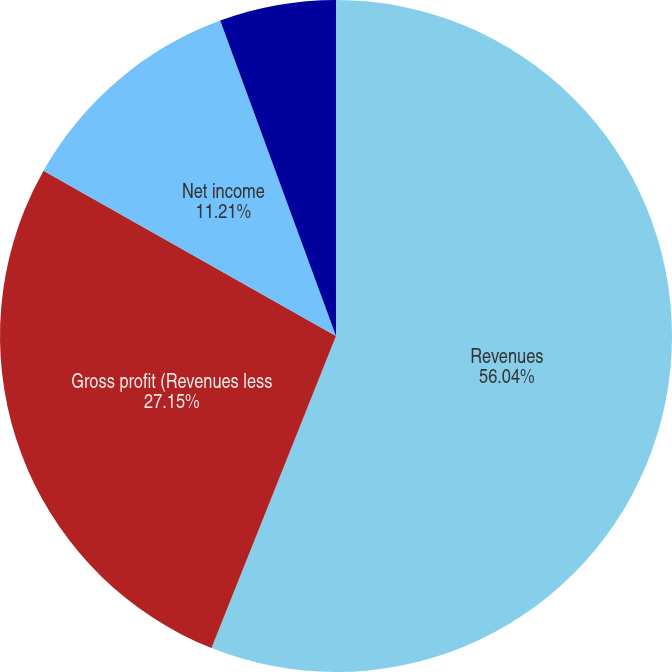Convert chart. <chart><loc_0><loc_0><loc_500><loc_500><pie_chart><fcel>Revenues<fcel>Gross profit (Revenues less<fcel>Net income<fcel>Income per share-Basic<fcel>Income per share-Diluted<nl><fcel>56.04%<fcel>27.15%<fcel>11.21%<fcel>0.0%<fcel>5.6%<nl></chart> 